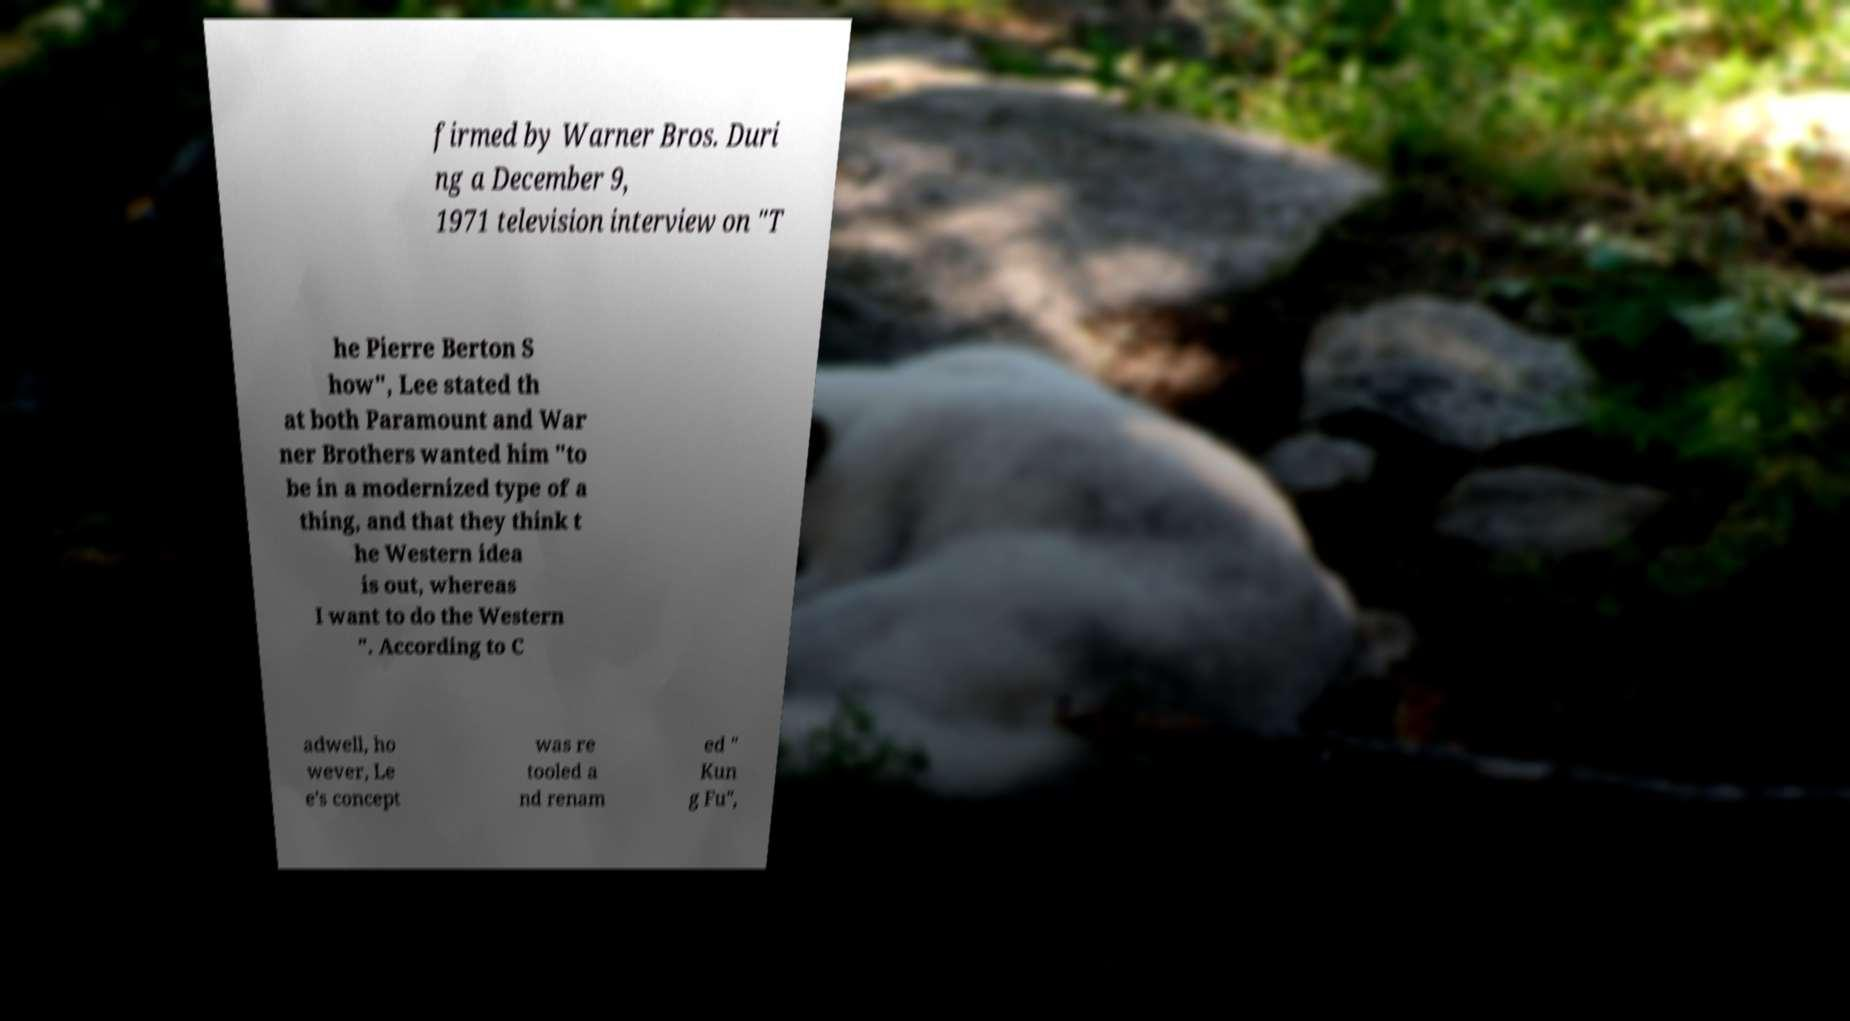What messages or text are displayed in this image? I need them in a readable, typed format. firmed by Warner Bros. Duri ng a December 9, 1971 television interview on "T he Pierre Berton S how", Lee stated th at both Paramount and War ner Brothers wanted him "to be in a modernized type of a thing, and that they think t he Western idea is out, whereas I want to do the Western ". According to C adwell, ho wever, Le e's concept was re tooled a nd renam ed " Kun g Fu", 